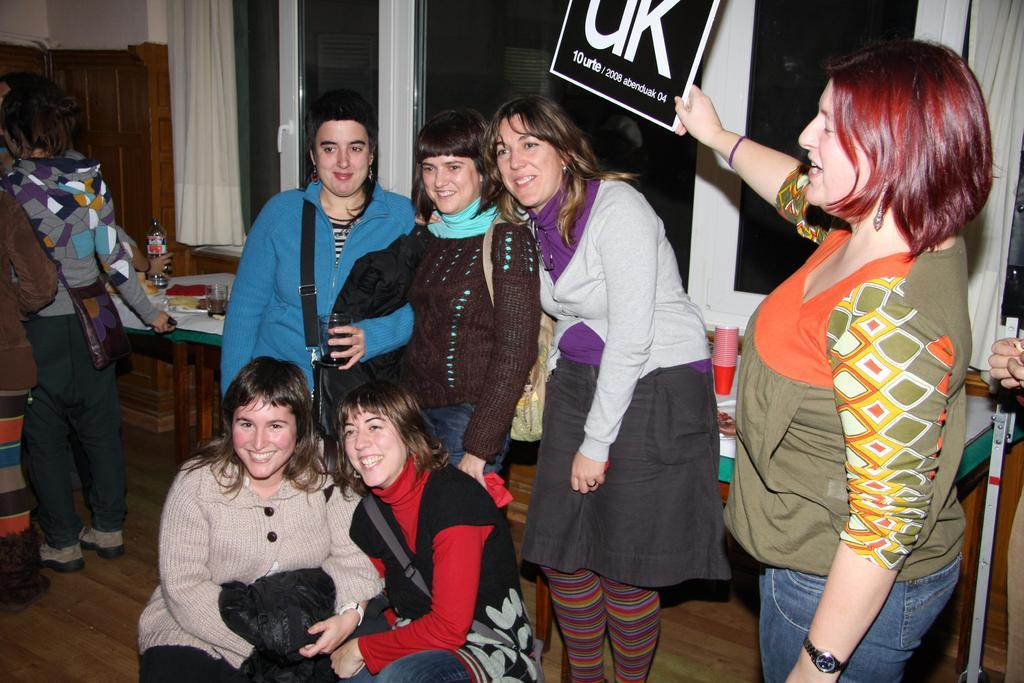What is happening with the group of people in the image? The group of people is on the floor in the image. What can be seen in the background of the room? In the background, there is a table, bottles, glasses, a cupboard, a wall, windows, and a curtain associated with the windows. What type of setting is the image taken in? The image is taken in a room. What type of drain is visible in the image? There is no drain present in the image. What kind of paper is being used by the people in the image? There is no paper visible in the image; it only shows a group of people on the floor and the background elements. 